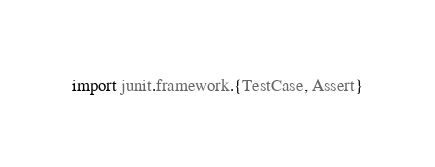<code> <loc_0><loc_0><loc_500><loc_500><_Scala_>
import junit.framework.{TestCase, Assert}</code> 